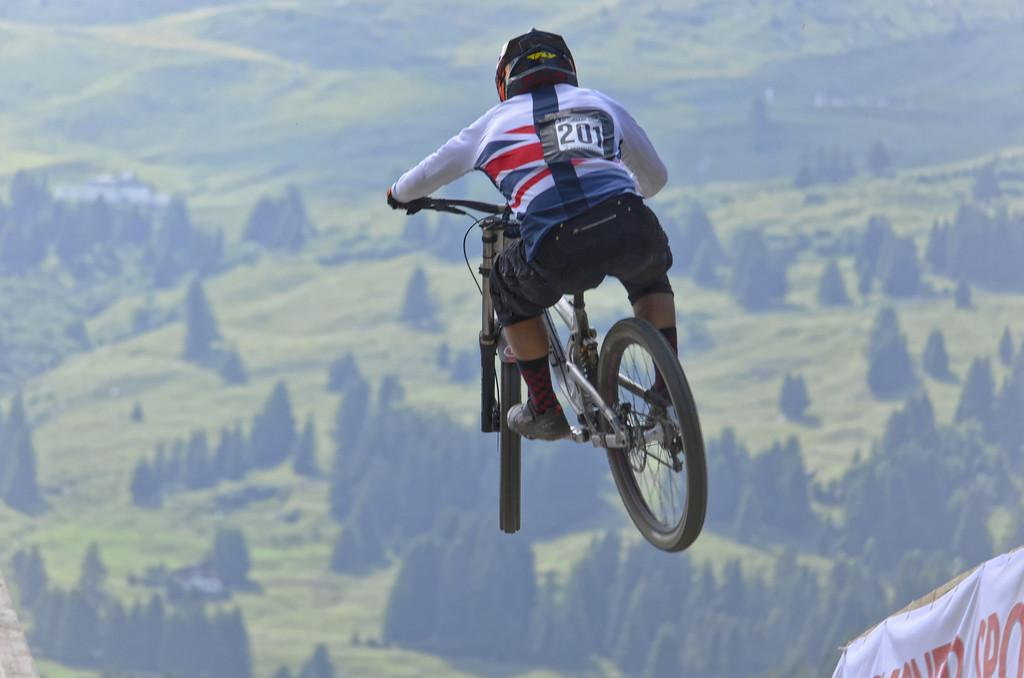What is the main subject of the image? There is a person in the image. What is the person wearing? The person is wearing a chest number and helmet. What is the person sitting on? The person is sitting on a cycle. What action is the person performing? The person is jumping. What can be seen in the background of the image? There are trees in the background of the image. Can you see a parcel being delivered by the person in the image? There is no parcel visible in the image, and the person is not shown delivering anything. What type of clam is being used as a prop in the image? There are no clams present in the image; it features a person wearing a chest number and helmet, sitting on a cycle, and jumping. 